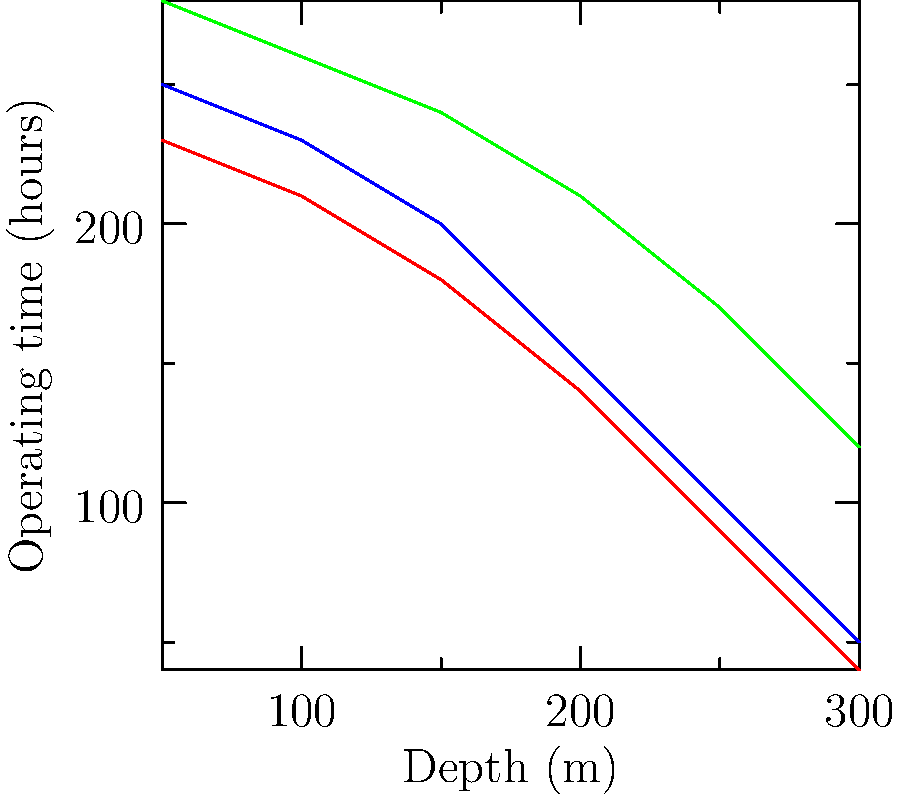Based on the cross-sectional diagram showing the depth capabilities of three German submarine models used in World War II, which type demonstrates the best overall performance in terms of operating time at various depths? To determine which submarine type demonstrates the best overall performance, we need to analyze the graph for each model:

1. Type VII (blue line):
   - Starts at 250 hours at 50m depth
   - Gradually decreases to 50 hours at 300m depth

2. Type IX (red line):
   - Starts at 230 hours at 50m depth
   - Gradually decreases to 40 hours at 300m depth

3. Type XXI (green line):
   - Starts at 280 hours at 50m depth
   - Gradually decreases to 120 hours at 300m depth

Comparing the three models:
- Type XXI consistently shows higher operating times across all depths.
- It starts with the highest operating time at 50m (280 hours).
- It maintains the highest operating time at all subsequent depths.
- At the maximum depth of 300m, Type XXI still operates for 120 hours, significantly outperforming the other two models.

Therefore, the Type XXI submarine demonstrates the best overall performance in terms of operating time at various depths.
Answer: Type XXI 